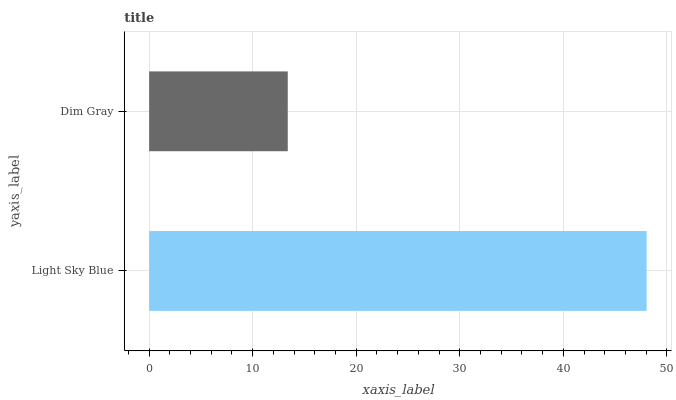Is Dim Gray the minimum?
Answer yes or no. Yes. Is Light Sky Blue the maximum?
Answer yes or no. Yes. Is Dim Gray the maximum?
Answer yes or no. No. Is Light Sky Blue greater than Dim Gray?
Answer yes or no. Yes. Is Dim Gray less than Light Sky Blue?
Answer yes or no. Yes. Is Dim Gray greater than Light Sky Blue?
Answer yes or no. No. Is Light Sky Blue less than Dim Gray?
Answer yes or no. No. Is Light Sky Blue the high median?
Answer yes or no. Yes. Is Dim Gray the low median?
Answer yes or no. Yes. Is Dim Gray the high median?
Answer yes or no. No. Is Light Sky Blue the low median?
Answer yes or no. No. 